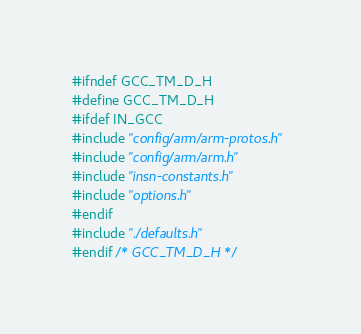Convert code to text. <code><loc_0><loc_0><loc_500><loc_500><_C_>#ifndef GCC_TM_D_H
#define GCC_TM_D_H
#ifdef IN_GCC
#include "config/arm/arm-protos.h"
#include "config/arm/arm.h"
#include "insn-constants.h"
#include "options.h"
#endif
#include "./defaults.h"
#endif /* GCC_TM_D_H */
</code> 